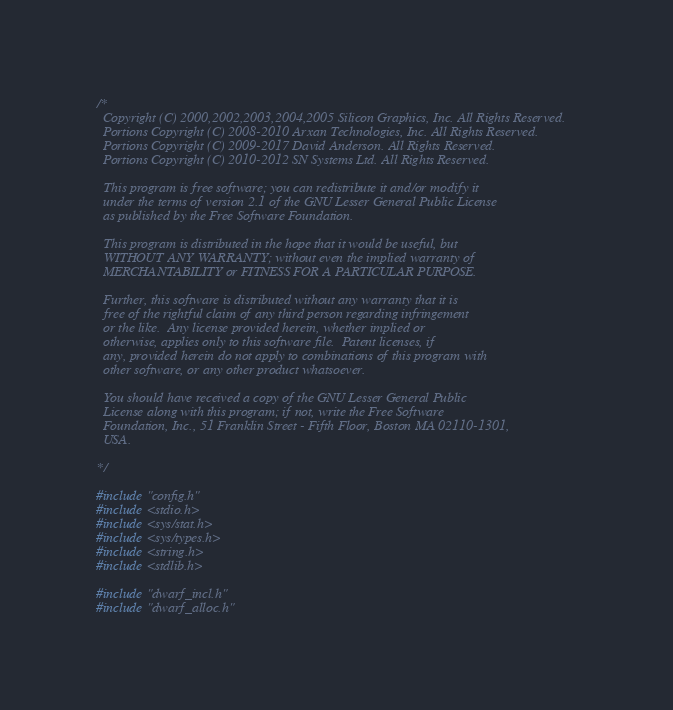<code> <loc_0><loc_0><loc_500><loc_500><_C_>/*
  Copyright (C) 2000,2002,2003,2004,2005 Silicon Graphics, Inc. All Rights Reserved.
  Portions Copyright (C) 2008-2010 Arxan Technologies, Inc. All Rights Reserved.
  Portions Copyright (C) 2009-2017 David Anderson. All Rights Reserved.
  Portions Copyright (C) 2010-2012 SN Systems Ltd. All Rights Reserved.

  This program is free software; you can redistribute it and/or modify it
  under the terms of version 2.1 of the GNU Lesser General Public License
  as published by the Free Software Foundation.

  This program is distributed in the hope that it would be useful, but
  WITHOUT ANY WARRANTY; without even the implied warranty of
  MERCHANTABILITY or FITNESS FOR A PARTICULAR PURPOSE.

  Further, this software is distributed without any warranty that it is
  free of the rightful claim of any third person regarding infringement
  or the like.  Any license provided herein, whether implied or
  otherwise, applies only to this software file.  Patent licenses, if
  any, provided herein do not apply to combinations of this program with
  other software, or any other product whatsoever.

  You should have received a copy of the GNU Lesser General Public
  License along with this program; if not, write the Free Software
  Foundation, Inc., 51 Franklin Street - Fifth Floor, Boston MA 02110-1301,
  USA.

*/

#include "config.h"
#include <stdio.h>
#include <sys/stat.h>
#include <sys/types.h>
#include <string.h>
#include <stdlib.h>

#include "dwarf_incl.h"
#include "dwarf_alloc.h"</code> 